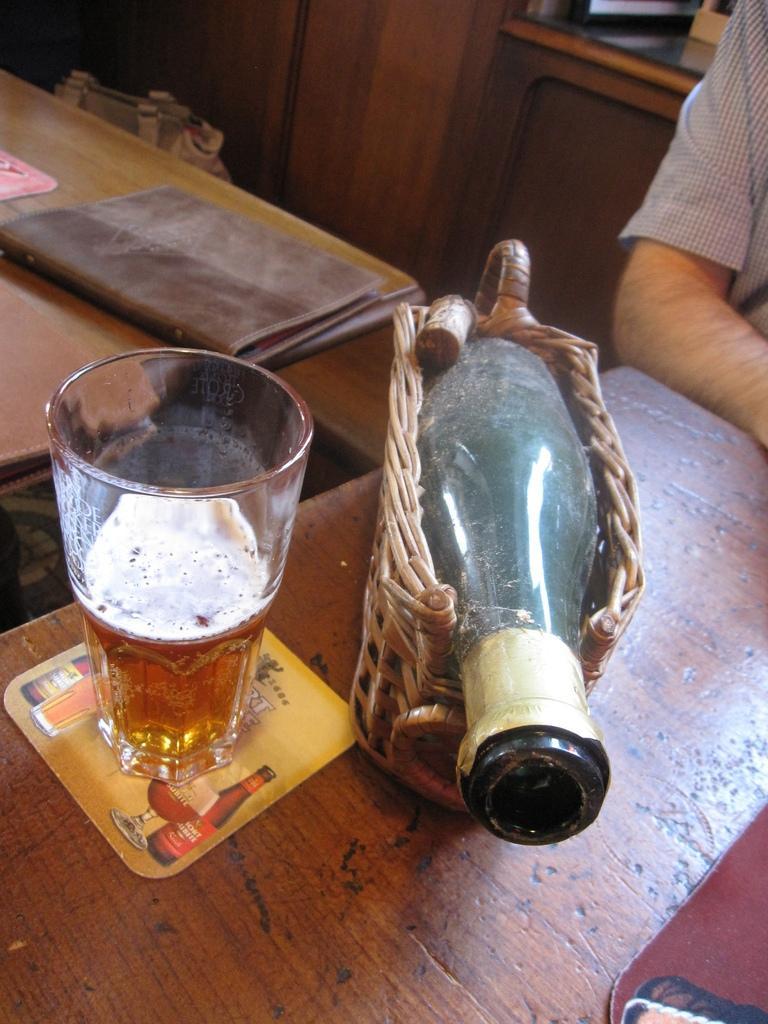In one or two sentences, can you explain what this image depicts? In this image I can see a glass,bottle and few objects on the brown color table. I can see a person,book and a cupboard. 